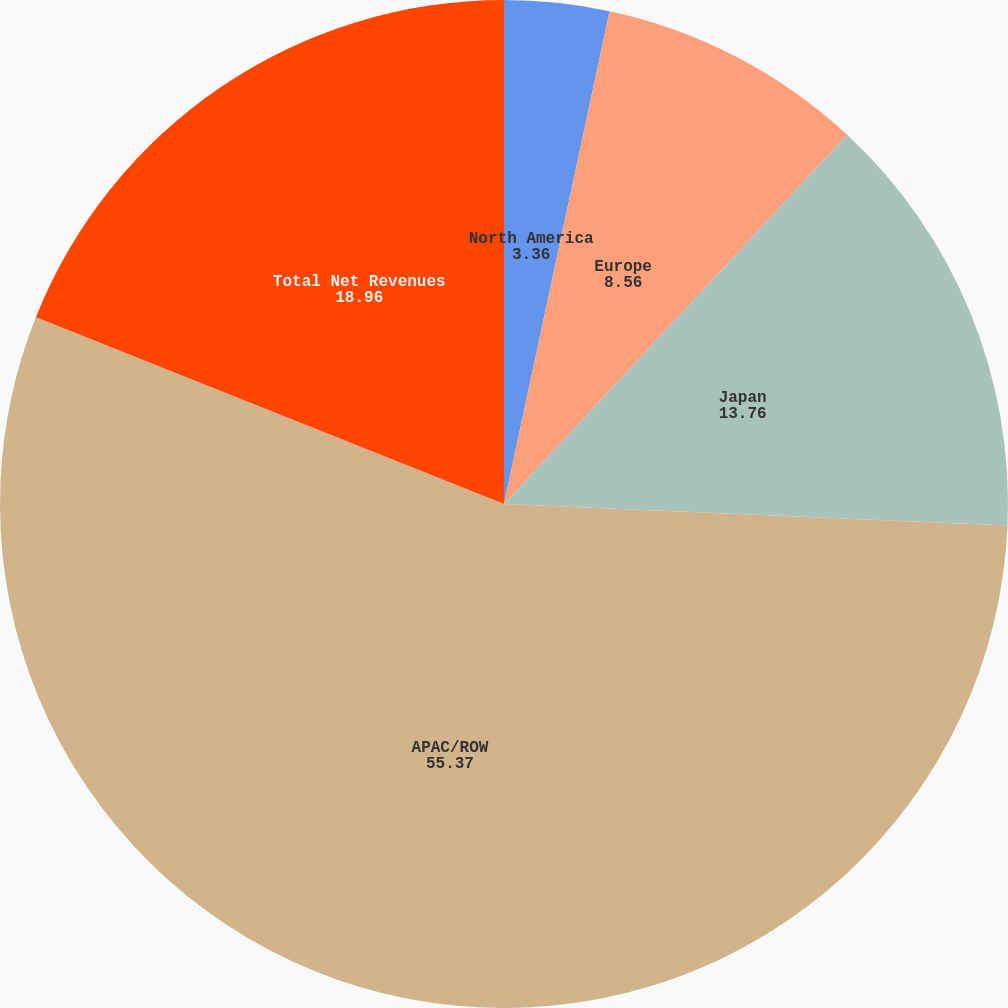Convert chart. <chart><loc_0><loc_0><loc_500><loc_500><pie_chart><fcel>North America<fcel>Europe<fcel>Japan<fcel>APAC/ROW<fcel>Total Net Revenues<nl><fcel>3.36%<fcel>8.56%<fcel>13.76%<fcel>55.37%<fcel>18.96%<nl></chart> 